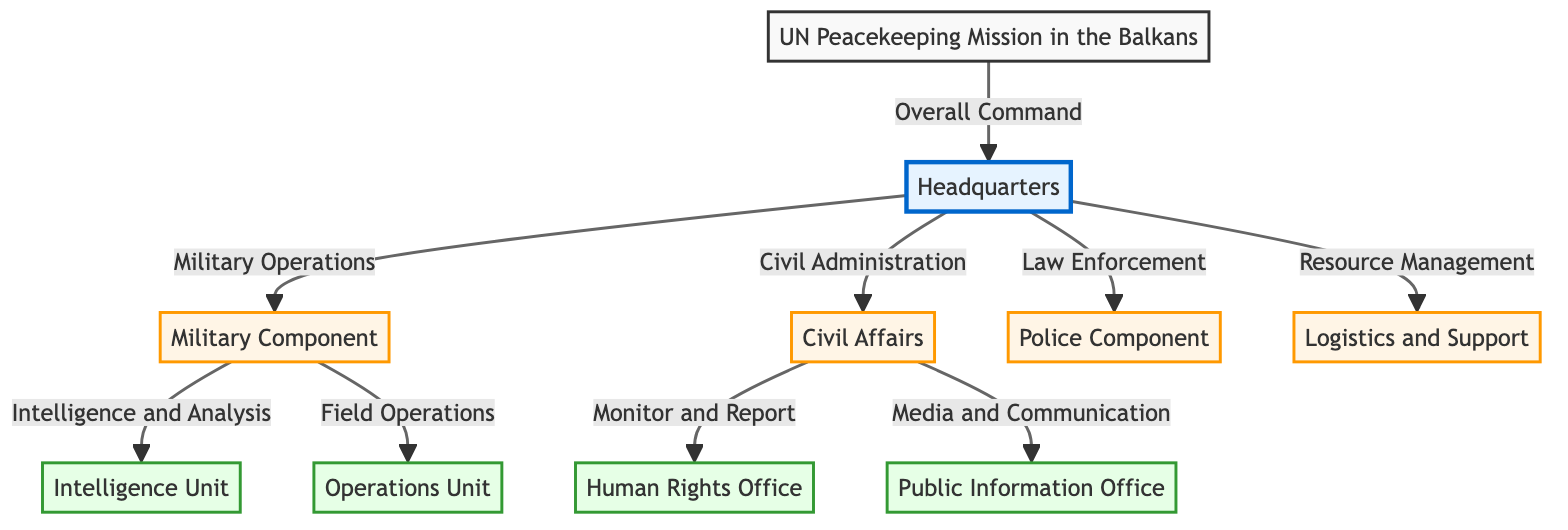What is the primary command structure of the diagram? The diagram indicates that the primary command is structured around the “UN Peacekeeping Mission in the Balkans,” which is at the top of the hierarchy. This mission is connected to the “Headquarters,” showing its overall command role.
Answer: UN Peacekeeping Mission in the Balkans How many main components are depicted in the diagram? The diagram contains five main components below the headquarters: Military Component, Civil Affairs, Police Component, Logistics and Support. This counts to four distinct components when totaling them in the flow.
Answer: 4 Which unit is responsible for intelligence and analysis? Following the diagram, the Intelligence Unit is directly linked to the Military Component, indicating its responsibility for intelligence and analysis as part of military operations.
Answer: Intelligence Unit What is the relationship between Civil Affairs and the Human Rights Office? The Civil Affairs component is responsible for monitoring and reporting, which is a task associated with the Human Rights Office. This indicates a functional relationship where one monitors aspects impacting the other.
Answer: Monitor and Report Identify the component that handles media and communication. The diagram indicates that the Public Information Office directly reports to the Civil Affairs component, which shows its role in handling media and communication.
Answer: Public Information Office What type of component is the Operations Unit? In the organizational chart, the Operations Unit is classified as a unit component under the Military Component, indicating its specific operational focus.
Answer: unit How many units are connected to the Military Component? The Military Component has two specific units depicted in the diagram: the Intelligence Unit and the Operations Unit. This gives a total of two units associated with the Military Component.
Answer: 2 Which component manages resource allocation? The Logistics and Support component is directly connected to the Headquarters and is responsible for resource management, as clearly outlined in the flowchart.
Answer: Logistics and Support What is the function of the Police Component? The Police Component is tasked with Law Enforcement, showing its primary function within the organizational structure.
Answer: Law Enforcement 